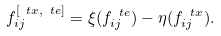Convert formula to latex. <formula><loc_0><loc_0><loc_500><loc_500>f _ { i j } ^ { [ \ t x , \ t e ] } = \xi ( f _ { i j } ^ { \ t e } ) - \eta ( f _ { i j } ^ { \ t x } ) .</formula> 